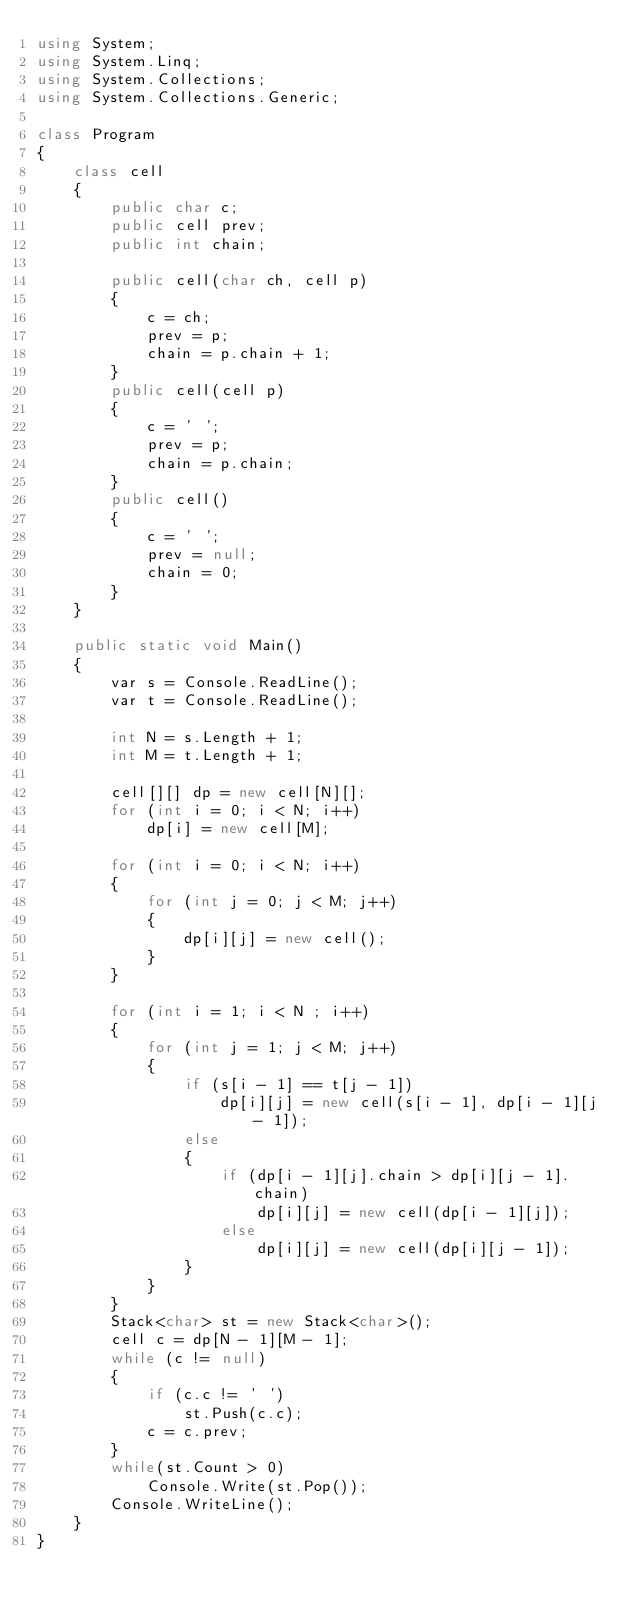Convert code to text. <code><loc_0><loc_0><loc_500><loc_500><_C#_>using System;
using System.Linq;
using System.Collections;
using System.Collections.Generic;

class Program
{
    class cell
    {
        public char c;
        public cell prev;
        public int chain;

        public cell(char ch, cell p)
        {
            c = ch;
            prev = p;
            chain = p.chain + 1;
        }
        public cell(cell p)
        {
            c = ' ';
            prev = p;
            chain = p.chain;
        }
        public cell()
        {
            c = ' ';
            prev = null;
            chain = 0;
        }
    }

    public static void Main()
    {
        var s = Console.ReadLine();
        var t = Console.ReadLine();

        int N = s.Length + 1;
        int M = t.Length + 1;

        cell[][] dp = new cell[N][];
        for (int i = 0; i < N; i++)
            dp[i] = new cell[M];

        for (int i = 0; i < N; i++)
        {
            for (int j = 0; j < M; j++)
            {
                dp[i][j] = new cell();
            }
        }

        for (int i = 1; i < N ; i++)
        {
            for (int j = 1; j < M; j++)
            {
                if (s[i - 1] == t[j - 1])
                    dp[i][j] = new cell(s[i - 1], dp[i - 1][j - 1]);
                else
                {
                    if (dp[i - 1][j].chain > dp[i][j - 1].chain)
                        dp[i][j] = new cell(dp[i - 1][j]);
                    else
                        dp[i][j] = new cell(dp[i][j - 1]);
                }
            }
        }
        Stack<char> st = new Stack<char>();
        cell c = dp[N - 1][M - 1];
        while (c != null)
        {
            if (c.c != ' ')
                st.Push(c.c);
            c = c.prev;
        }
        while(st.Count > 0)
            Console.Write(st.Pop());
        Console.WriteLine();
    }
}</code> 